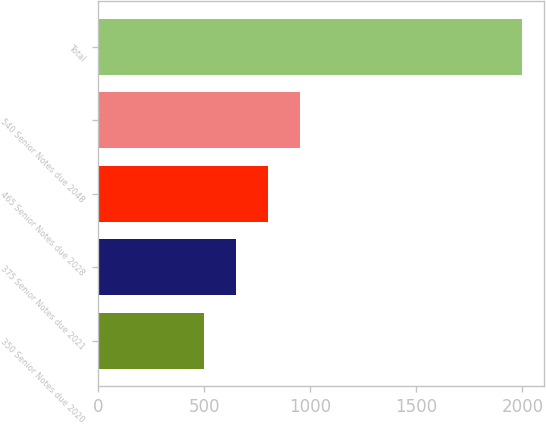Convert chart. <chart><loc_0><loc_0><loc_500><loc_500><bar_chart><fcel>350 Senior Notes due 2020<fcel>375 Senior Notes due 2021<fcel>465 Senior Notes due 2028<fcel>540 Senior Notes due 2048<fcel>Total<nl><fcel>500<fcel>650<fcel>800<fcel>950<fcel>2000<nl></chart> 